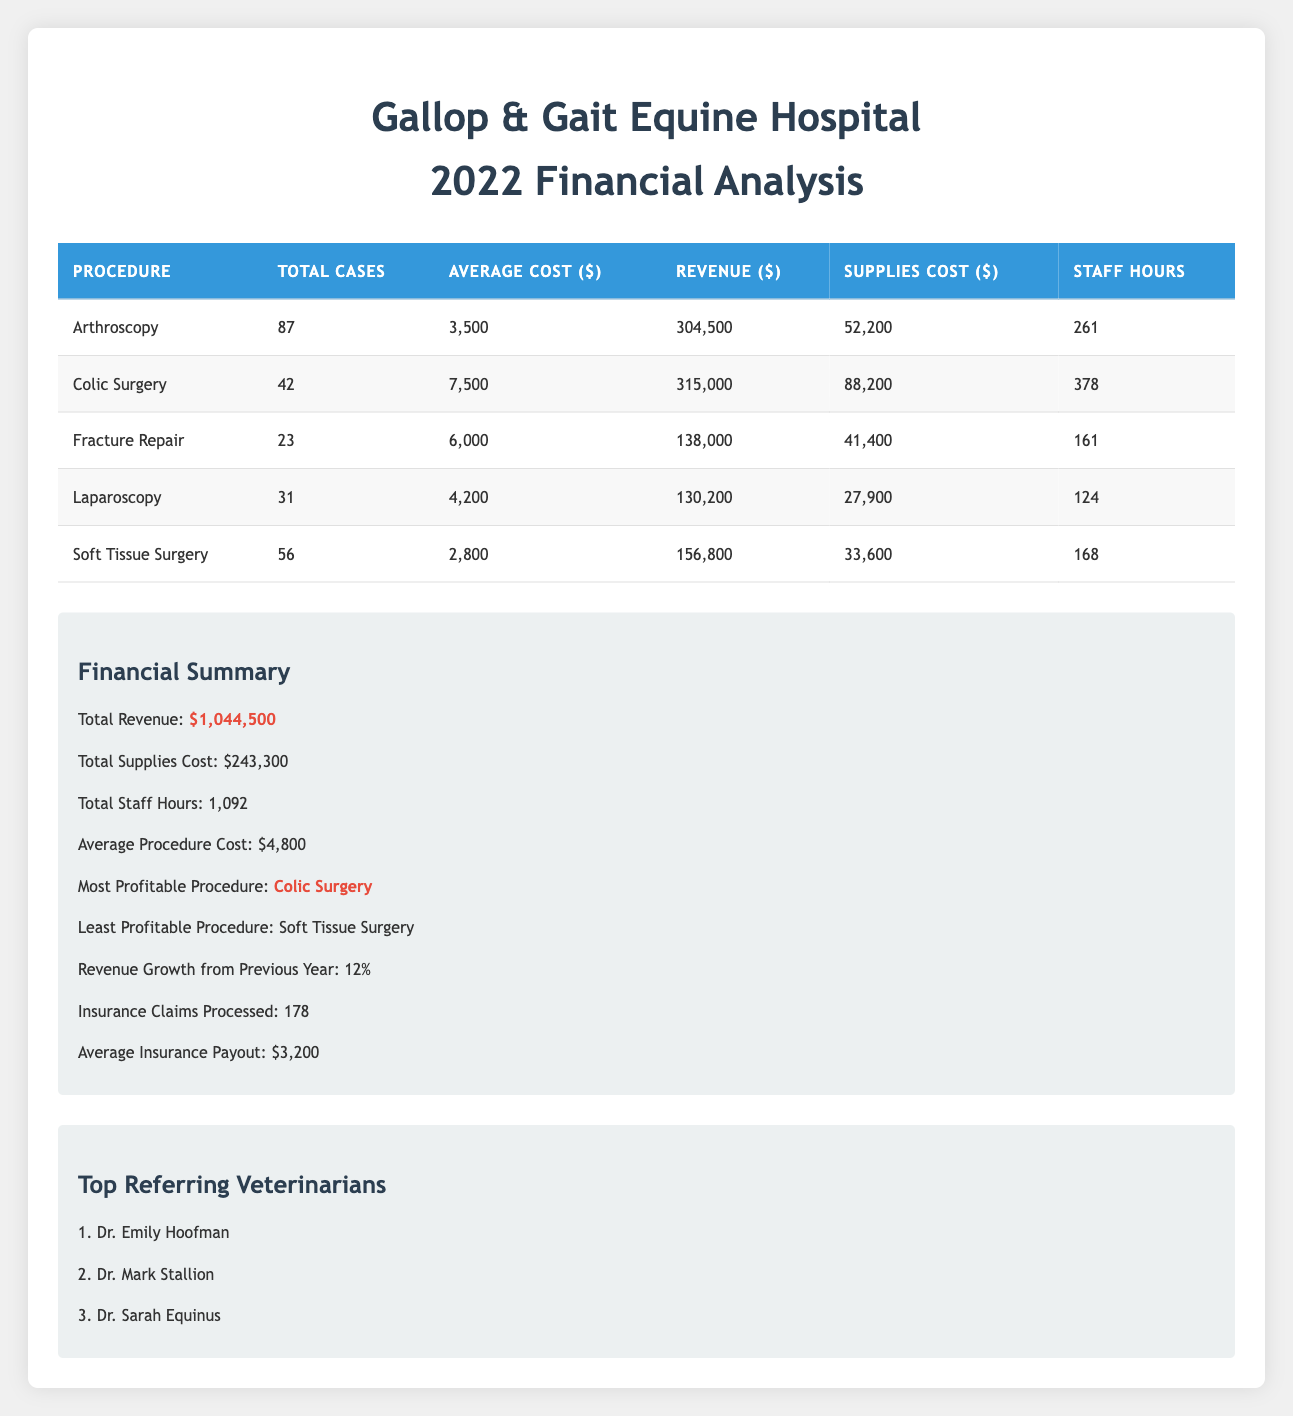What is the total revenue generated from all surgical procedures? The total revenue is provided in the financial summary section. It shows that the total revenue from all surgical procedures was $1,044,500.
Answer: 1,044,500 Which surgical procedure had the highest average cost? By comparing the average costs listed for each procedure, Colic Surgery has the highest average cost at $7,500.
Answer: Colic Surgery What is the average supplies cost across all procedures? The supplies costs for each procedure are summed up: 52,200 + 88,200 + 41,400 + 27,900 + 33,600 = 243,300. Then, to find the average, we divide the total supplies cost by the number of procedures: 243,300 / 5 = 48,660.
Answer: 48,660 Did the clinic process more insurance claims than last year? The table indicates that the clinic processed 178 insurance claims in 2022. Without previous year data, we cannot determine if this is more or less, so it can't be answered with the current information.
Answer: Unknown How many total staff hours were devoted to surgical procedures throughout the year? The total staff hours are explicitly stated in the summary section. The total was 1,092 hours worked by staff for all surgical procedures.
Answer: 1,092 What is the difference in revenue between the most profitable and least profitable procedures? The most profitable procedure, Colic Surgery, generated $315,000, while the least profitable, Soft Tissue Surgery, generated $156,800. The difference is $315,000 - $156,800 = $158,200.
Answer: 158,200 Is the average insurance payout higher than the average cost of procedures? The average insurance payout is $3,200, and the average cost of procedures is $4,800. Since $3,200 is less than $4,800, the statement is false.
Answer: No How many surgical procedures had more than 35 cases? By examining the total cases for each procedure, Arthroscopy (87), Colic Surgery (42), and Soft Tissue Surgery (56) surpassed 35 cases. This sums to 3 procedures having more than 35 cases.
Answer: 3 What were the top referring veterinarians? The table contains a specific section listing the top referring veterinarians as Dr. Emily Hoofman, Dr. Mark Stallion, and Dr. Sarah Equinus.
Answer: Dr. Emily Hoofman, Dr. Mark Stallion, Dr. Sarah Equinus 